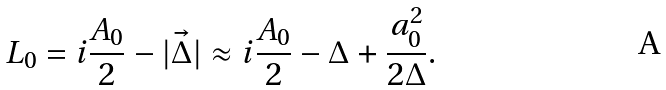Convert formula to latex. <formula><loc_0><loc_0><loc_500><loc_500>L _ { 0 } = i \frac { A _ { 0 } } { 2 } - | \vec { \Delta } | \approx i \frac { A _ { 0 } } { 2 } - \Delta + \frac { a _ { 0 } ^ { 2 } } { 2 \Delta } .</formula> 